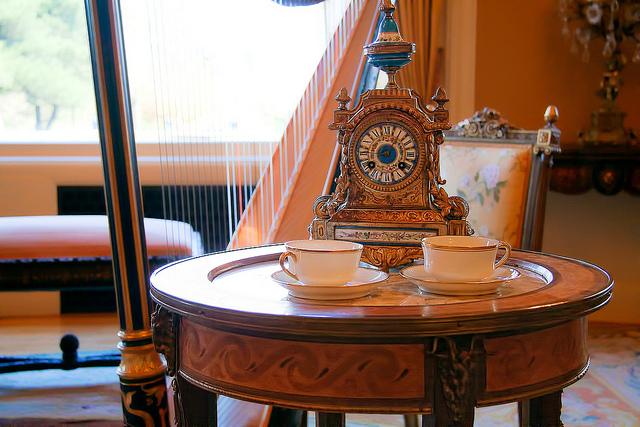IS this a poor person's house?
Concise answer only. No. Is anyone taking tea?
Write a very short answer. No. What can be seen outside the window?
Concise answer only. Tree. 